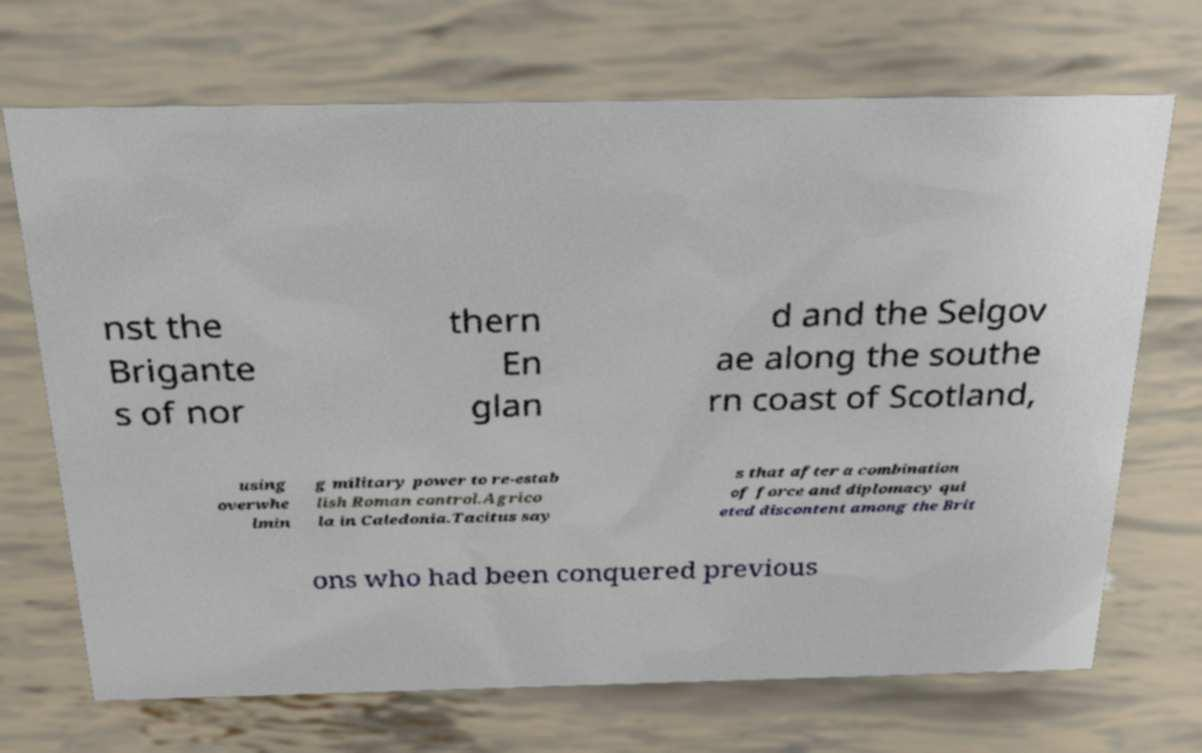Can you accurately transcribe the text from the provided image for me? nst the Brigante s of nor thern En glan d and the Selgov ae along the southe rn coast of Scotland, using overwhe lmin g military power to re-estab lish Roman control.Agrico la in Caledonia.Tacitus say s that after a combination of force and diplomacy qui eted discontent among the Brit ons who had been conquered previous 